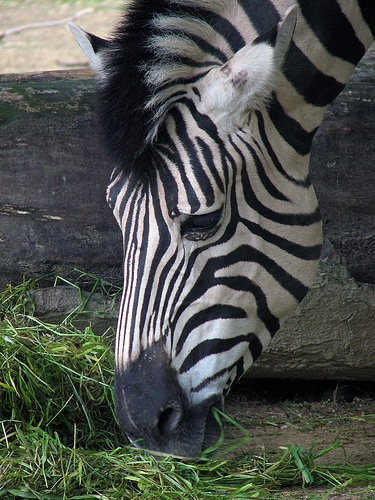Describe the objects in this image and their specific colors. I can see a zebra in darkgray, black, gray, and lightgray tones in this image. 